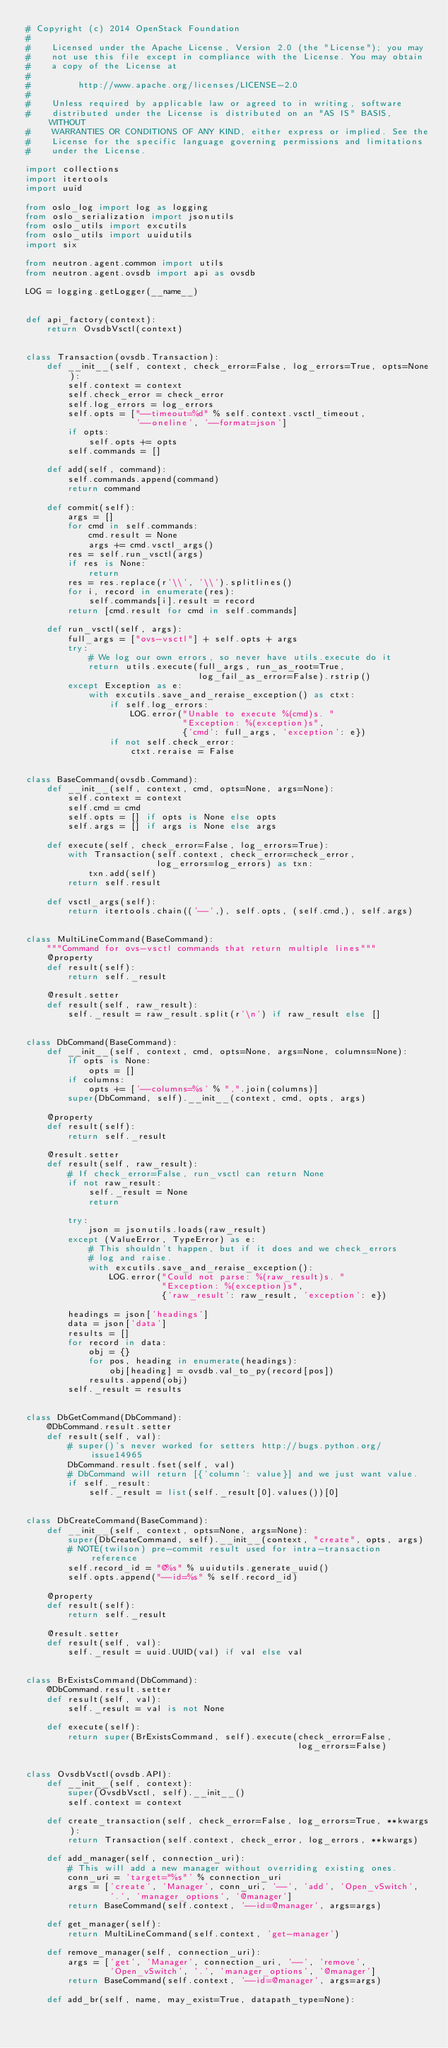<code> <loc_0><loc_0><loc_500><loc_500><_Python_># Copyright (c) 2014 OpenStack Foundation
#
#    Licensed under the Apache License, Version 2.0 (the "License"); you may
#    not use this file except in compliance with the License. You may obtain
#    a copy of the License at
#
#         http://www.apache.org/licenses/LICENSE-2.0
#
#    Unless required by applicable law or agreed to in writing, software
#    distributed under the License is distributed on an "AS IS" BASIS, WITHOUT
#    WARRANTIES OR CONDITIONS OF ANY KIND, either express or implied. See the
#    License for the specific language governing permissions and limitations
#    under the License.

import collections
import itertools
import uuid

from oslo_log import log as logging
from oslo_serialization import jsonutils
from oslo_utils import excutils
from oslo_utils import uuidutils
import six

from neutron.agent.common import utils
from neutron.agent.ovsdb import api as ovsdb

LOG = logging.getLogger(__name__)


def api_factory(context):
    return OvsdbVsctl(context)


class Transaction(ovsdb.Transaction):
    def __init__(self, context, check_error=False, log_errors=True, opts=None):
        self.context = context
        self.check_error = check_error
        self.log_errors = log_errors
        self.opts = ["--timeout=%d" % self.context.vsctl_timeout,
                     '--oneline', '--format=json']
        if opts:
            self.opts += opts
        self.commands = []

    def add(self, command):
        self.commands.append(command)
        return command

    def commit(self):
        args = []
        for cmd in self.commands:
            cmd.result = None
            args += cmd.vsctl_args()
        res = self.run_vsctl(args)
        if res is None:
            return
        res = res.replace(r'\\', '\\').splitlines()
        for i, record in enumerate(res):
            self.commands[i].result = record
        return [cmd.result for cmd in self.commands]

    def run_vsctl(self, args):
        full_args = ["ovs-vsctl"] + self.opts + args
        try:
            # We log our own errors, so never have utils.execute do it
            return utils.execute(full_args, run_as_root=True,
                                 log_fail_as_error=False).rstrip()
        except Exception as e:
            with excutils.save_and_reraise_exception() as ctxt:
                if self.log_errors:
                    LOG.error("Unable to execute %(cmd)s. "
                              "Exception: %(exception)s",
                              {'cmd': full_args, 'exception': e})
                if not self.check_error:
                    ctxt.reraise = False


class BaseCommand(ovsdb.Command):
    def __init__(self, context, cmd, opts=None, args=None):
        self.context = context
        self.cmd = cmd
        self.opts = [] if opts is None else opts
        self.args = [] if args is None else args

    def execute(self, check_error=False, log_errors=True):
        with Transaction(self.context, check_error=check_error,
                         log_errors=log_errors) as txn:
            txn.add(self)
        return self.result

    def vsctl_args(self):
        return itertools.chain(('--',), self.opts, (self.cmd,), self.args)


class MultiLineCommand(BaseCommand):
    """Command for ovs-vsctl commands that return multiple lines"""
    @property
    def result(self):
        return self._result

    @result.setter
    def result(self, raw_result):
        self._result = raw_result.split(r'\n') if raw_result else []


class DbCommand(BaseCommand):
    def __init__(self, context, cmd, opts=None, args=None, columns=None):
        if opts is None:
            opts = []
        if columns:
            opts += ['--columns=%s' % ",".join(columns)]
        super(DbCommand, self).__init__(context, cmd, opts, args)

    @property
    def result(self):
        return self._result

    @result.setter
    def result(self, raw_result):
        # If check_error=False, run_vsctl can return None
        if not raw_result:
            self._result = None
            return

        try:
            json = jsonutils.loads(raw_result)
        except (ValueError, TypeError) as e:
            # This shouldn't happen, but if it does and we check_errors
            # log and raise.
            with excutils.save_and_reraise_exception():
                LOG.error("Could not parse: %(raw_result)s. "
                          "Exception: %(exception)s",
                          {'raw_result': raw_result, 'exception': e})

        headings = json['headings']
        data = json['data']
        results = []
        for record in data:
            obj = {}
            for pos, heading in enumerate(headings):
                obj[heading] = ovsdb.val_to_py(record[pos])
            results.append(obj)
        self._result = results


class DbGetCommand(DbCommand):
    @DbCommand.result.setter
    def result(self, val):
        # super()'s never worked for setters http://bugs.python.org/issue14965
        DbCommand.result.fset(self, val)
        # DbCommand will return [{'column': value}] and we just want value.
        if self._result:
            self._result = list(self._result[0].values())[0]


class DbCreateCommand(BaseCommand):
    def __init__(self, context, opts=None, args=None):
        super(DbCreateCommand, self).__init__(context, "create", opts, args)
        # NOTE(twilson) pre-commit result used for intra-transaction reference
        self.record_id = "@%s" % uuidutils.generate_uuid()
        self.opts.append("--id=%s" % self.record_id)

    @property
    def result(self):
        return self._result

    @result.setter
    def result(self, val):
        self._result = uuid.UUID(val) if val else val


class BrExistsCommand(DbCommand):
    @DbCommand.result.setter
    def result(self, val):
        self._result = val is not None

    def execute(self):
        return super(BrExistsCommand, self).execute(check_error=False,
                                                    log_errors=False)


class OvsdbVsctl(ovsdb.API):
    def __init__(self, context):
        super(OvsdbVsctl, self).__init__()
        self.context = context

    def create_transaction(self, check_error=False, log_errors=True, **kwargs):
        return Transaction(self.context, check_error, log_errors, **kwargs)

    def add_manager(self, connection_uri):
        # This will add a new manager without overriding existing ones.
        conn_uri = 'target="%s"' % connection_uri
        args = ['create', 'Manager', conn_uri, '--', 'add', 'Open_vSwitch',
                '.', 'manager_options', '@manager']
        return BaseCommand(self.context, '--id=@manager', args=args)

    def get_manager(self):
        return MultiLineCommand(self.context, 'get-manager')

    def remove_manager(self, connection_uri):
        args = ['get', 'Manager', connection_uri, '--', 'remove',
                'Open_vSwitch', '.', 'manager_options', '@manager']
        return BaseCommand(self.context, '--id=@manager', args=args)

    def add_br(self, name, may_exist=True, datapath_type=None):</code> 